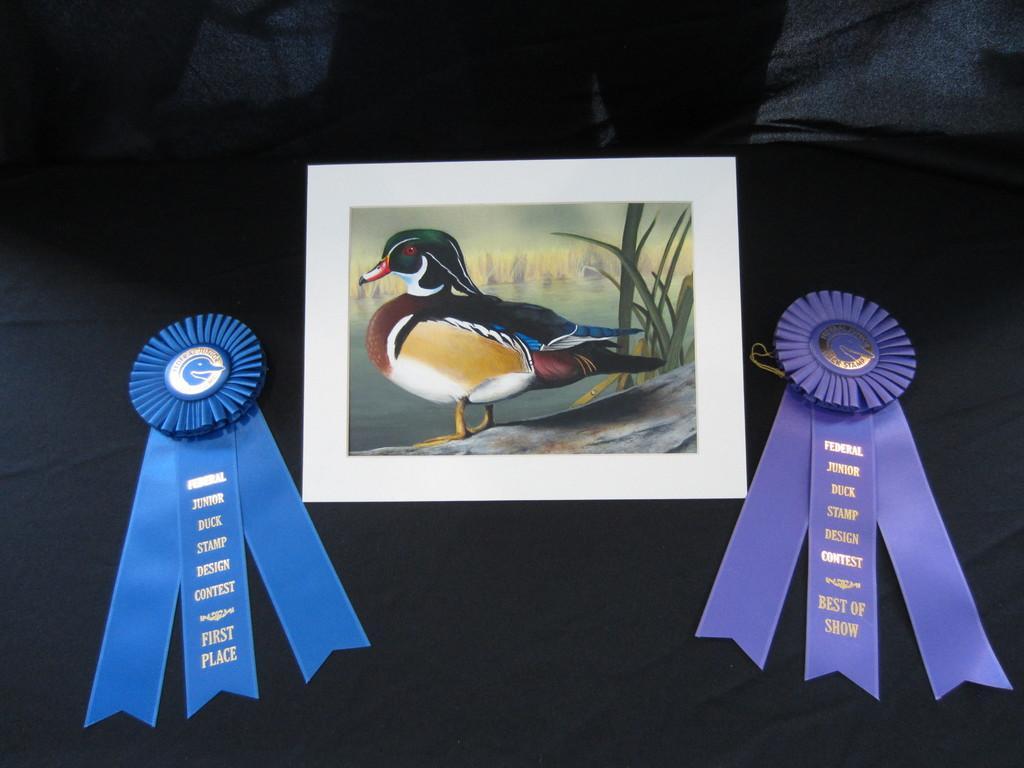Please provide a concise description of this image. In the foreground of this image, there are two ribbon batches and a frame on the black surface. 